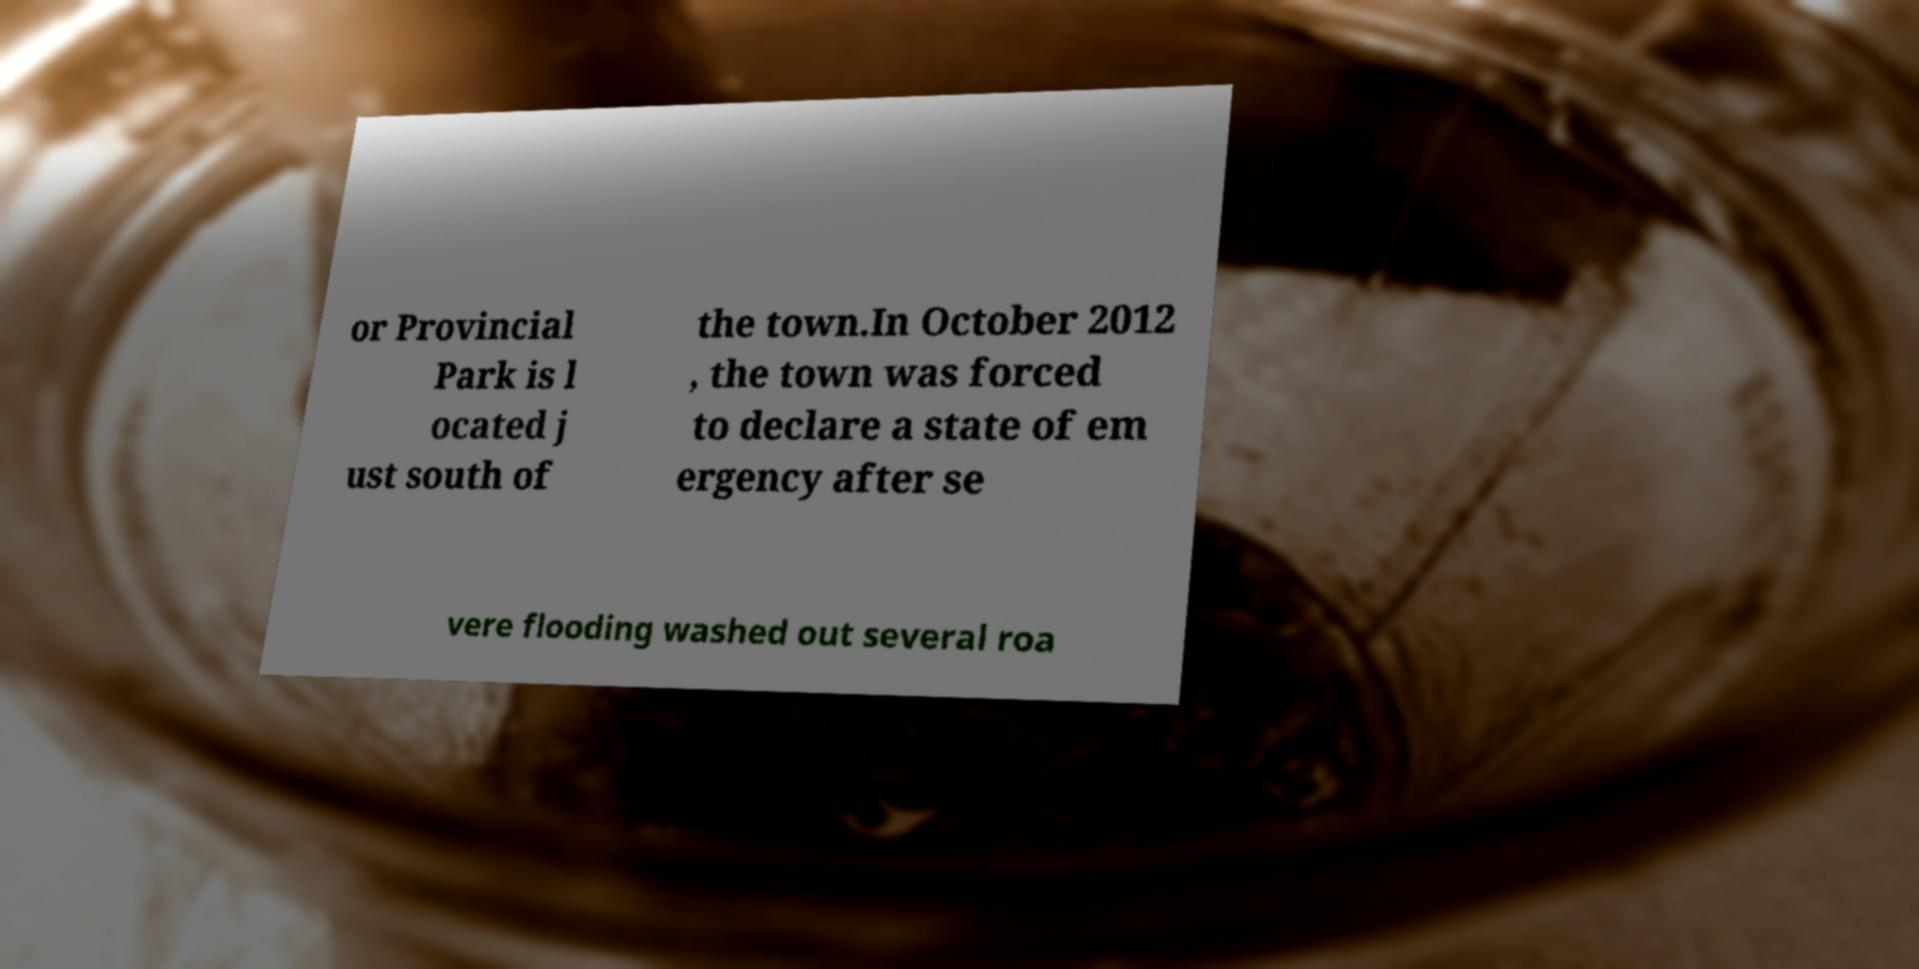For documentation purposes, I need the text within this image transcribed. Could you provide that? or Provincial Park is l ocated j ust south of the town.In October 2012 , the town was forced to declare a state of em ergency after se vere flooding washed out several roa 